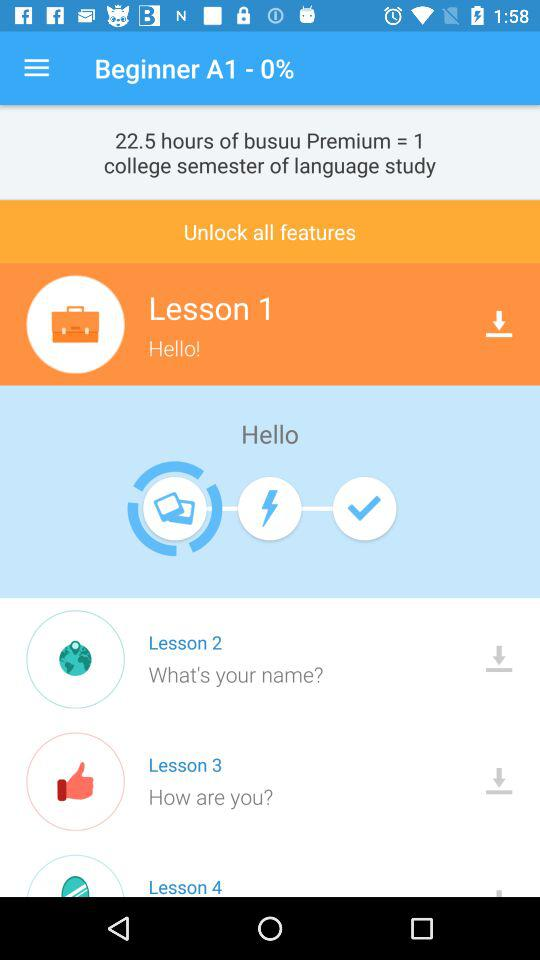How many lessons are there?
Answer the question using a single word or phrase. 4 